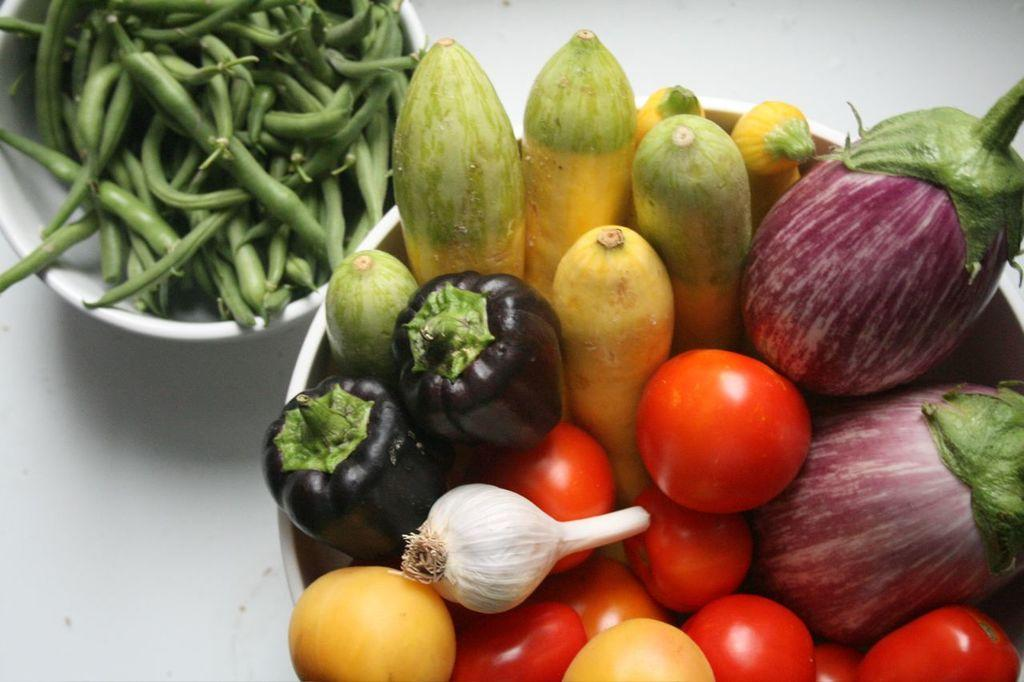What type of food is visible in the image? There are vegetables in the image. How are the vegetables arranged or contained? The vegetables are in bowls. What other objects can be seen in the image besides the vegetables? There are balls in the image. On what surface are the balls placed? The balls are placed on a white surface. How many crates are visible in the image? There are no crates present in the image. What type of boats can be seen sailing in the background of the image? There is no background or boats visible in the image. 